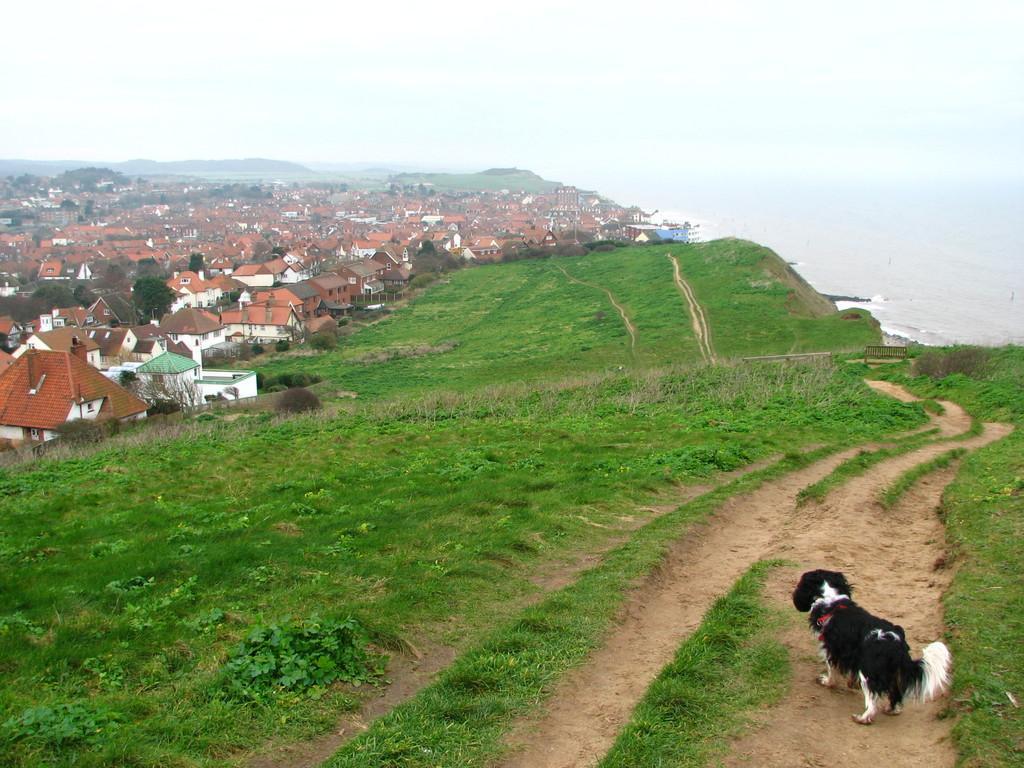Please provide a concise description of this image. In this picture I can see few buildings and I can see grass on the ground and I can see hill, bench and water and I can see sky and a dog. 